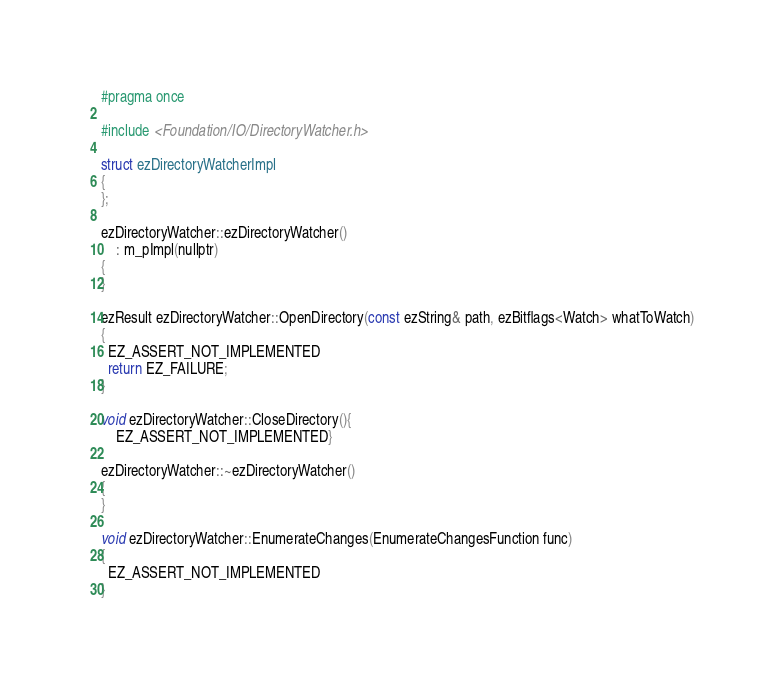Convert code to text. <code><loc_0><loc_0><loc_500><loc_500><_C_>#pragma once

#include <Foundation/IO/DirectoryWatcher.h>

struct ezDirectoryWatcherImpl
{
};

ezDirectoryWatcher::ezDirectoryWatcher()
    : m_pImpl(nullptr)
{
}

ezResult ezDirectoryWatcher::OpenDirectory(const ezString& path, ezBitflags<Watch> whatToWatch)
{
  EZ_ASSERT_NOT_IMPLEMENTED
  return EZ_FAILURE;
}

void ezDirectoryWatcher::CloseDirectory(){
    EZ_ASSERT_NOT_IMPLEMENTED}

ezDirectoryWatcher::~ezDirectoryWatcher()
{
}

void ezDirectoryWatcher::EnumerateChanges(EnumerateChangesFunction func)
{
  EZ_ASSERT_NOT_IMPLEMENTED
}

</code> 